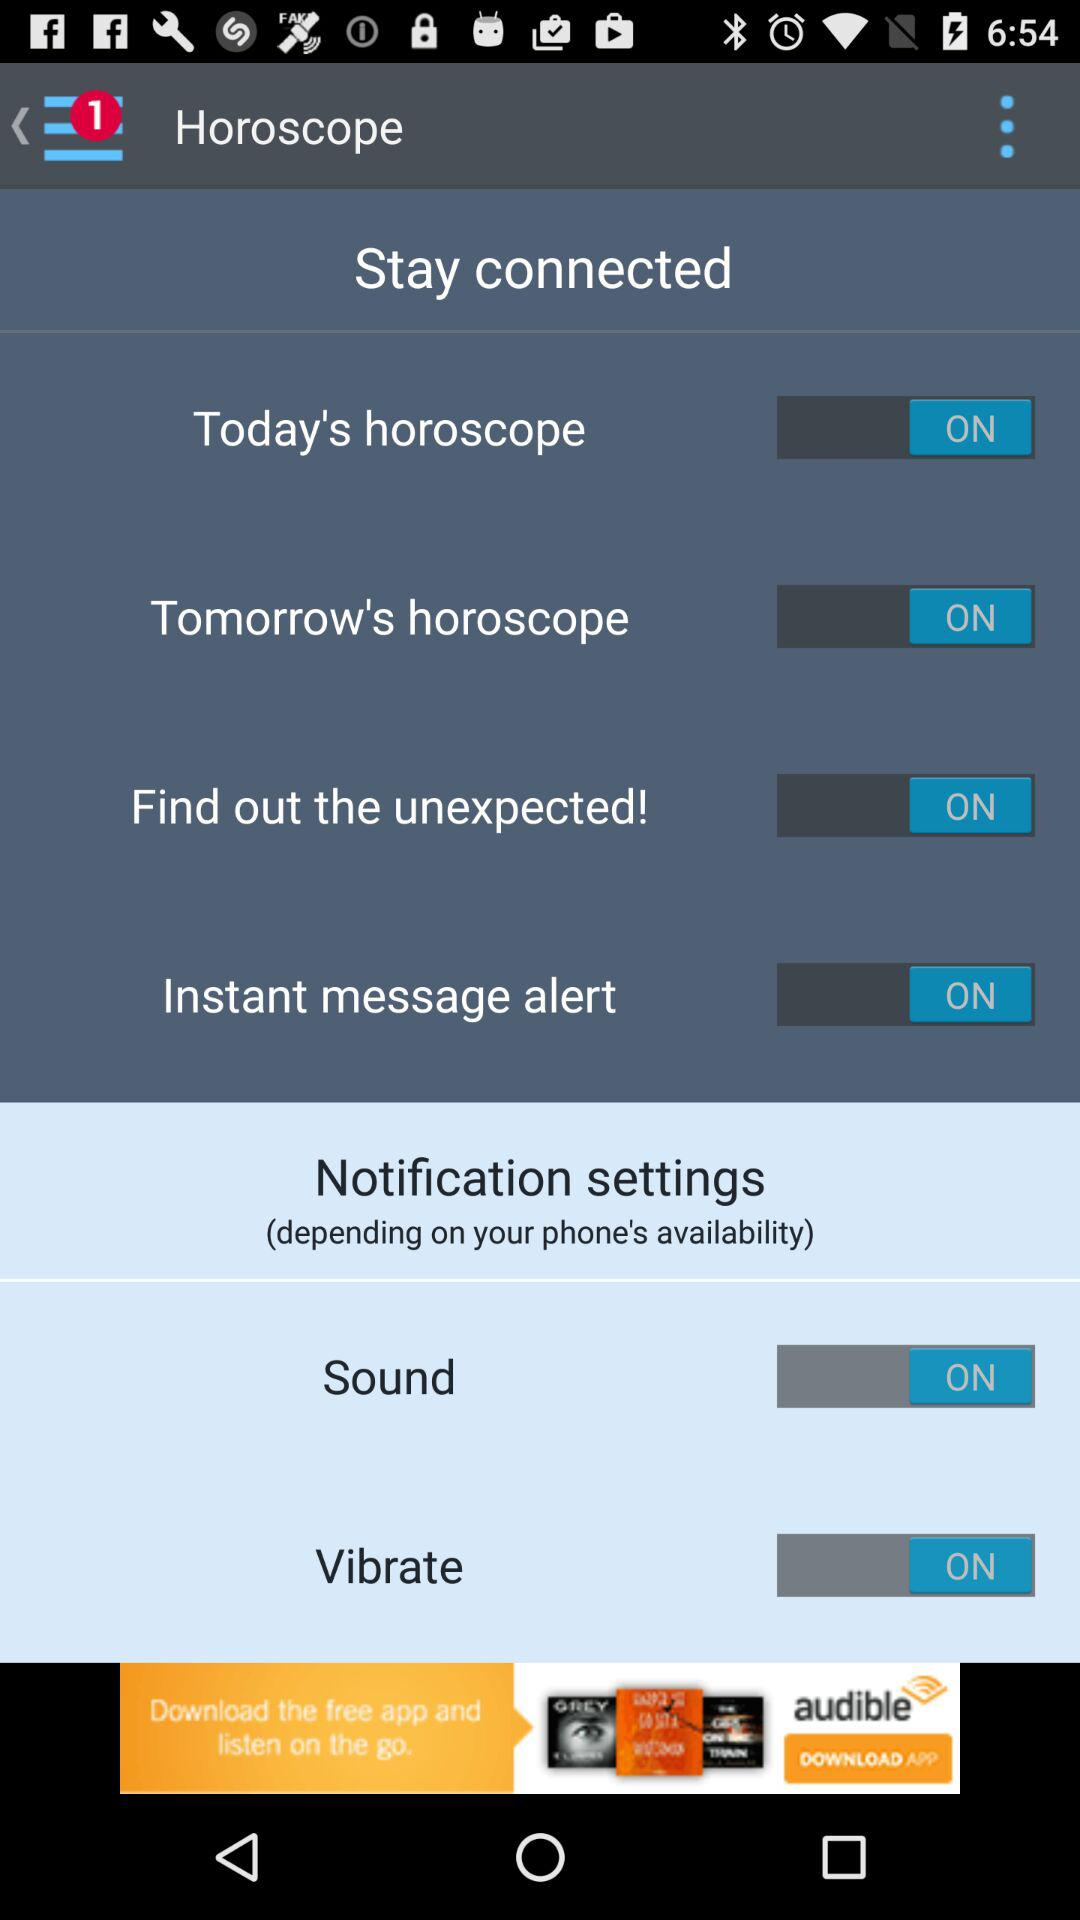What is the application name? The application name is "Horoscope". 